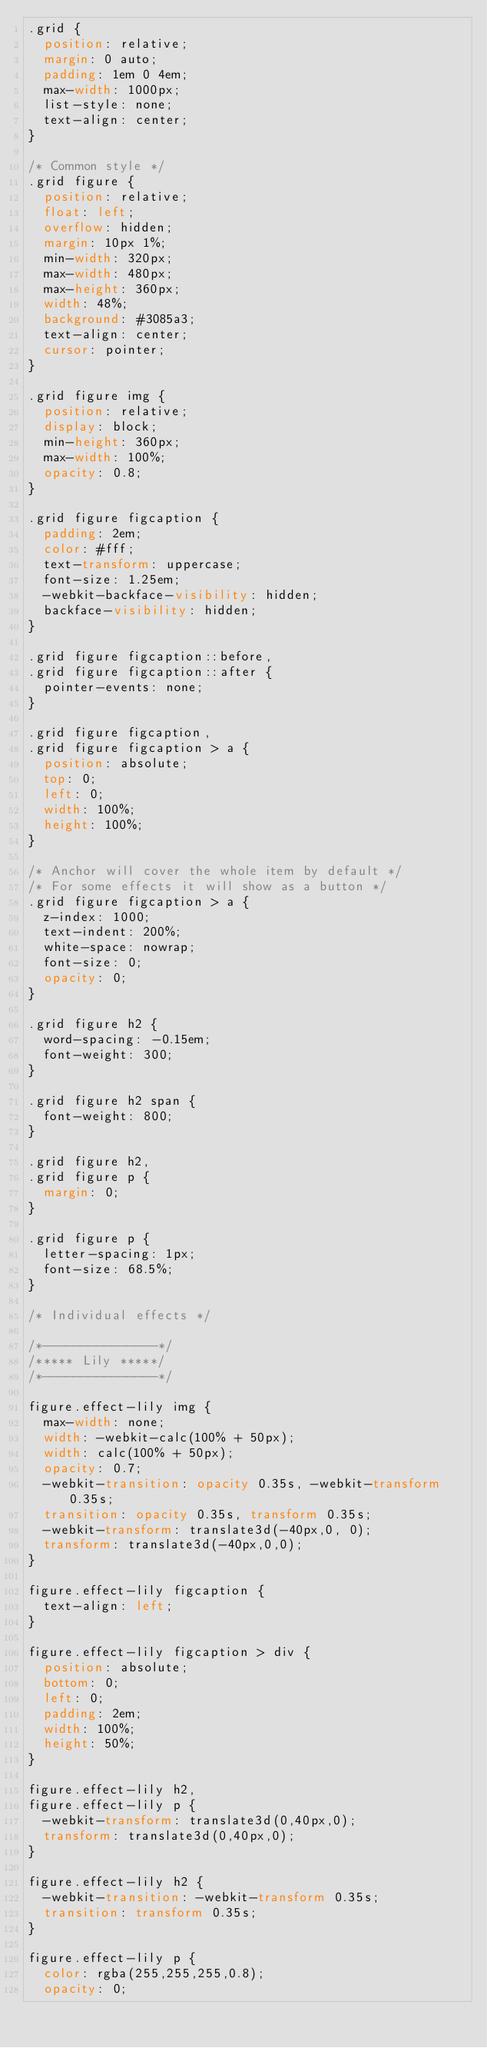Convert code to text. <code><loc_0><loc_0><loc_500><loc_500><_CSS_>.grid {
  position: relative;
  margin: 0 auto;
  padding: 1em 0 4em;
  max-width: 1000px;
  list-style: none;
  text-align: center;
}

/* Common style */
.grid figure {
  position: relative;
  float: left;
  overflow: hidden;
  margin: 10px 1%;
  min-width: 320px;
  max-width: 480px;
  max-height: 360px;
  width: 48%;
  background: #3085a3;
  text-align: center;
  cursor: pointer;
}

.grid figure img {
  position: relative;
  display: block;
  min-height: 360px;
  max-width: 100%;
  opacity: 0.8;
}

.grid figure figcaption {
  padding: 2em;
  color: #fff;
  text-transform: uppercase;
  font-size: 1.25em;
  -webkit-backface-visibility: hidden;
  backface-visibility: hidden;
}

.grid figure figcaption::before,
.grid figure figcaption::after {
  pointer-events: none;
}

.grid figure figcaption,
.grid figure figcaption > a {
  position: absolute;
  top: 0;
  left: 0;
  width: 100%;
  height: 100%;
}

/* Anchor will cover the whole item by default */
/* For some effects it will show as a button */
.grid figure figcaption > a {
  z-index: 1000;
  text-indent: 200%;
  white-space: nowrap;
  font-size: 0;
  opacity: 0;
}

.grid figure h2 {
  word-spacing: -0.15em;
  font-weight: 300;
}

.grid figure h2 span {
  font-weight: 800;
}

.grid figure h2,
.grid figure p {
  margin: 0;
}

.grid figure p {
  letter-spacing: 1px;
  font-size: 68.5%;
}

/* Individual effects */

/*---------------*/
/***** Lily *****/
/*---------------*/

figure.effect-lily img {
  max-width: none;
  width: -webkit-calc(100% + 50px);
  width: calc(100% + 50px);
  opacity: 0.7;
  -webkit-transition: opacity 0.35s, -webkit-transform 0.35s;
  transition: opacity 0.35s, transform 0.35s;
  -webkit-transform: translate3d(-40px,0, 0);
  transform: translate3d(-40px,0,0);
}

figure.effect-lily figcaption {
  text-align: left;
}

figure.effect-lily figcaption > div {
  position: absolute;
  bottom: 0;
  left: 0;
  padding: 2em;
  width: 100%;
  height: 50%;
}

figure.effect-lily h2,
figure.effect-lily p {
  -webkit-transform: translate3d(0,40px,0);
  transform: translate3d(0,40px,0);
}

figure.effect-lily h2 {
  -webkit-transition: -webkit-transform 0.35s;
  transition: transform 0.35s;
}

figure.effect-lily p {
  color: rgba(255,255,255,0.8);
  opacity: 0;</code> 